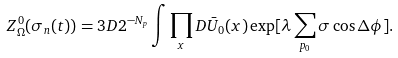<formula> <loc_0><loc_0><loc_500><loc_500>Z ^ { 0 } _ { \Omega } ( \sigma _ { n } ( t ) ) = 3 D 2 ^ { - N _ { p } } \int \prod _ { x } D \bar { U } _ { 0 } ( x ) \exp [ \lambda \sum _ { p _ { 0 } } \sigma \cos \Delta \phi ] .</formula> 